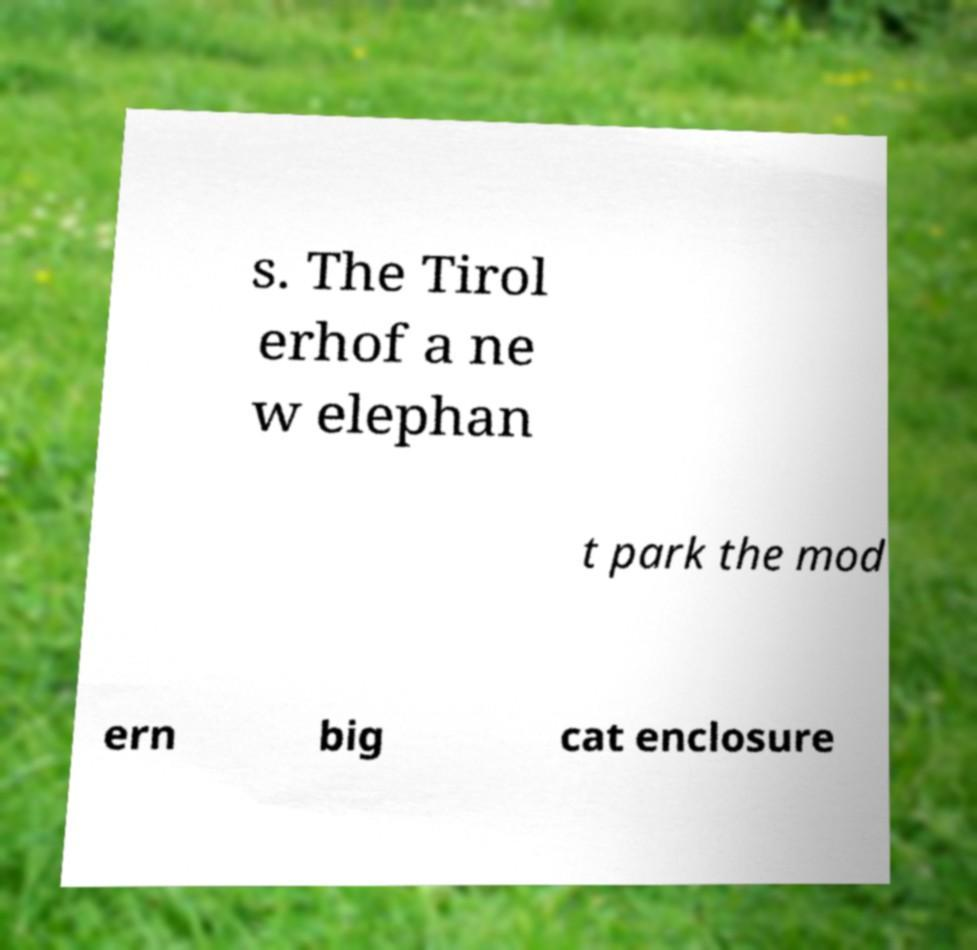Can you accurately transcribe the text from the provided image for me? s. The Tirol erhof a ne w elephan t park the mod ern big cat enclosure 